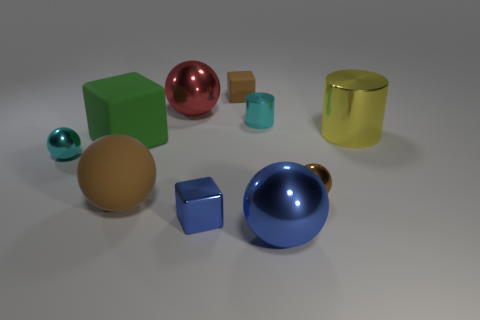What is the lighting situation like in this scene? The lighting in the scene is soft and diffused, coming from a direction that is not directly visible in the image. It casts gentle shadows, indicating a single, possibly overhead, light source. This lighting setup contributes to the smooth and slightly reflective surface appearances, emphasizing the objects' colors and shapes. 